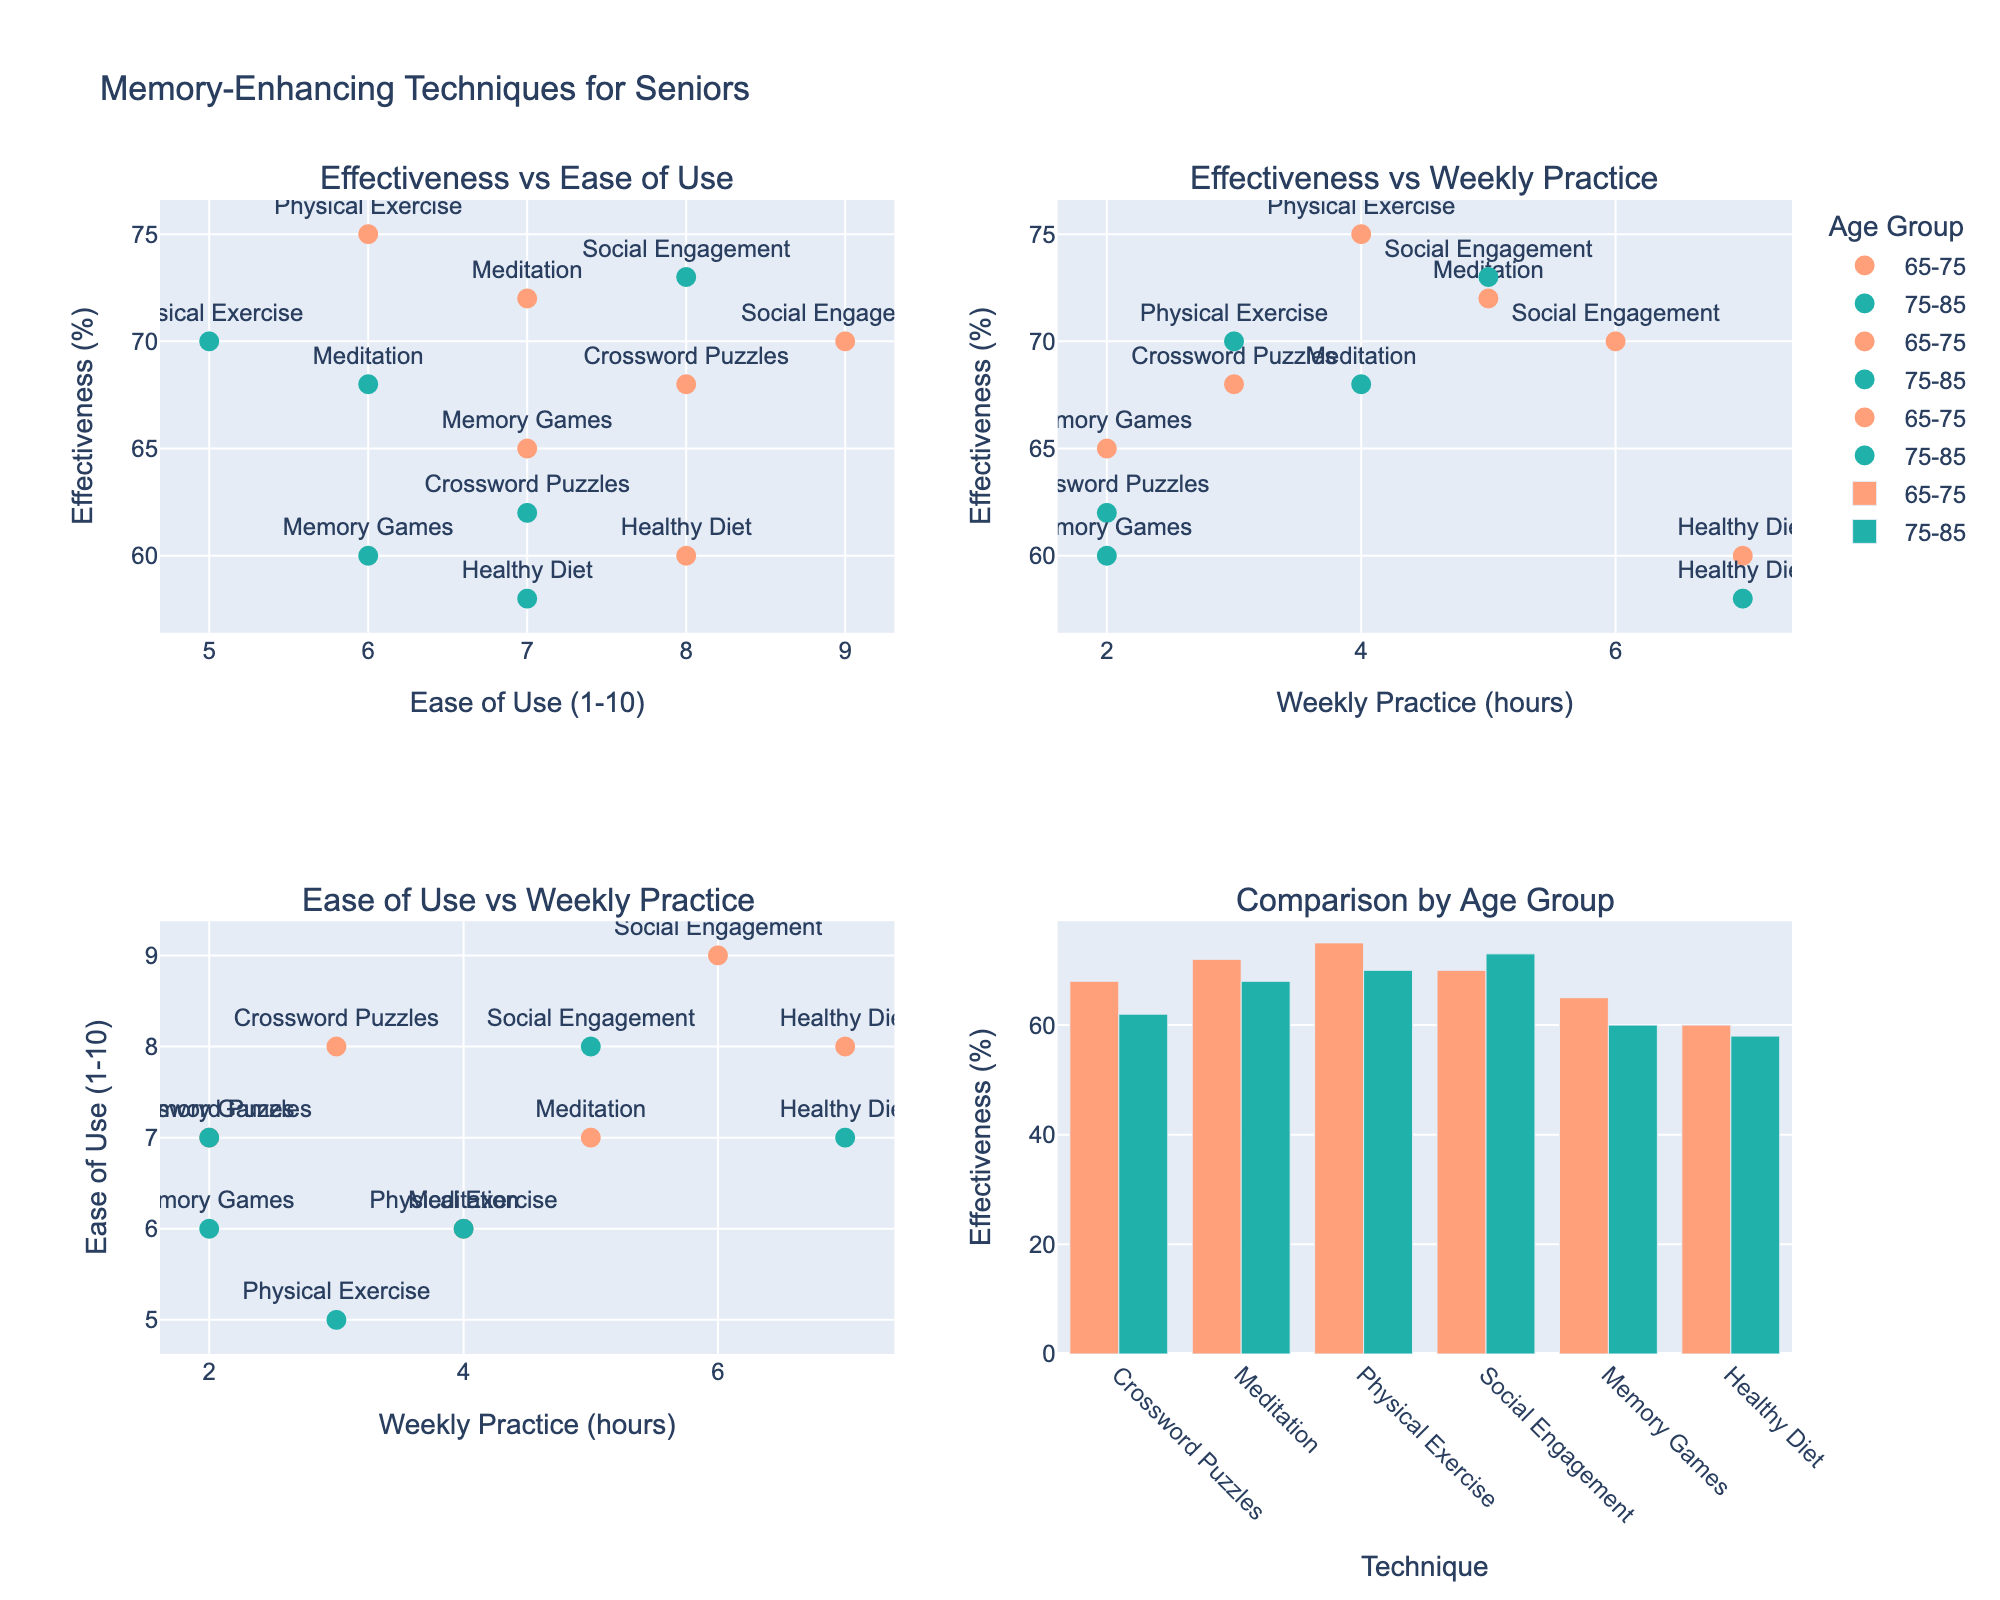Which county has a higher telemedicine adoption rate for Mental Health services in the 18-30 age group? By examining the subplot for Mental Health services, we compare the points for the 18-30 age group in Johnson County and Franklin County. Franklin County has a higher adoption rate (75%) compared to Johnson County (78%).
Answer: Johnson County What is the gap in Improved Health Outcomes between the 31-50 age group and the 51+ age group for Primary Care services in Franklin County? By looking at the Primary Care subplot for Franklin County, we find that the Improved Health Outcomes for the 31-50 age group is 65%, and for the 51+ age group, it is 54%. The gap is calculated as 65% - 54% = 11%.
Answer: 11% Which service type has the highest Improved Health Outcomes for the 31-50 age group in Johnson County? In the Johnson County subplots, we compare the 31-50 age group across service types: Primary Care (68%), Mental Health (79%), and Chronic Disease Management (74%). Mental Health has the highest outcome at 79%.
Answer: Mental Health How does the telemedicine adoption rate correlate with Improved Health Outcomes for Chronic Disease Management services for the 51+ age group in Johnson County? For Chronic Disease Management in Johnson County, the telemedicine adoption rate for the 51+ age group is 62% with an Improved Health Outcomes of 69%. There is a positive correlation since higher adoption correlates to higher health outcomes than other points within the same service type.
Answer: Positive correlation In which county does the 18-30 age group have better health outcomes for Primary Care services at similar adoption rates? By comparing corresponding points in the Primary Care subplots for Johnson and Franklin counties, both have similar adoption rates around 62-65%. Johnson County has better Improved Health Outcomes (72%) compared to Franklin County (70%).
Answer: Johnson County What can be said about the trend of Improved Health Outcomes for all age groups in the Mental Health service type across both counties? By analyzing the Mental Health subplots, it becomes evident across both counties that Improved Health Outcomes are generally higher for younger age groups (18-30) and gradually decrease as the age group increases (31-50, 51+).
Answer: Younger groups have better outcomes Compare the impact of telemedicine adoption on Improved Health Outcomes for Primary Care services between the 51+ age group in both counties. For the 51+ age group in Primary Care, Johnson County has a telemedicine adoption rate of 42% and an outcome of 57%, whereas Franklin County has a rate of 40% and an outcome of 54%. Both the adoption rates and outcomes are slightly higher in Johnson County.
Answer: Johnson County Which age group has the smallest difference in Improved Health Outcomes between Johnson County and Franklin County for Chronic Disease Management services? For Chronic Disease Management, comparing the Improved Health Outcomes across the age groups:
   - 18-30: Johnson 76%, Franklin 74% (difference 2%)
   - 31-50: Johnson 74%, Franklin 72% (difference 2%)
   - 51+: Johnson 69%, Franklin 67% (difference 2%)
Each age group has the same smallest difference of 2%.
Answer: All age groups Of the counties, which one demonstrates a stronger relationship between telemedicine adoption and Improved Health Outcomes for Mental Health services across all age groups? In the Mental Health subplot, Johnson County consistently shows higher Improved Health Outcomes at every adoption rate compared to Franklin County, indicating a stronger relationship.
Answer: Johnson County Which county and service type shows the widest range of Improved Health Outcomes for the 31-50 age group? By looking at the ranges across the subplots for both counties, we find that Mental Health services in Johnson County ranges from 68% to 79% for the 31-50 age group, which is a range of 11 percentage points.
Answer: Mental Health in Johnson County 